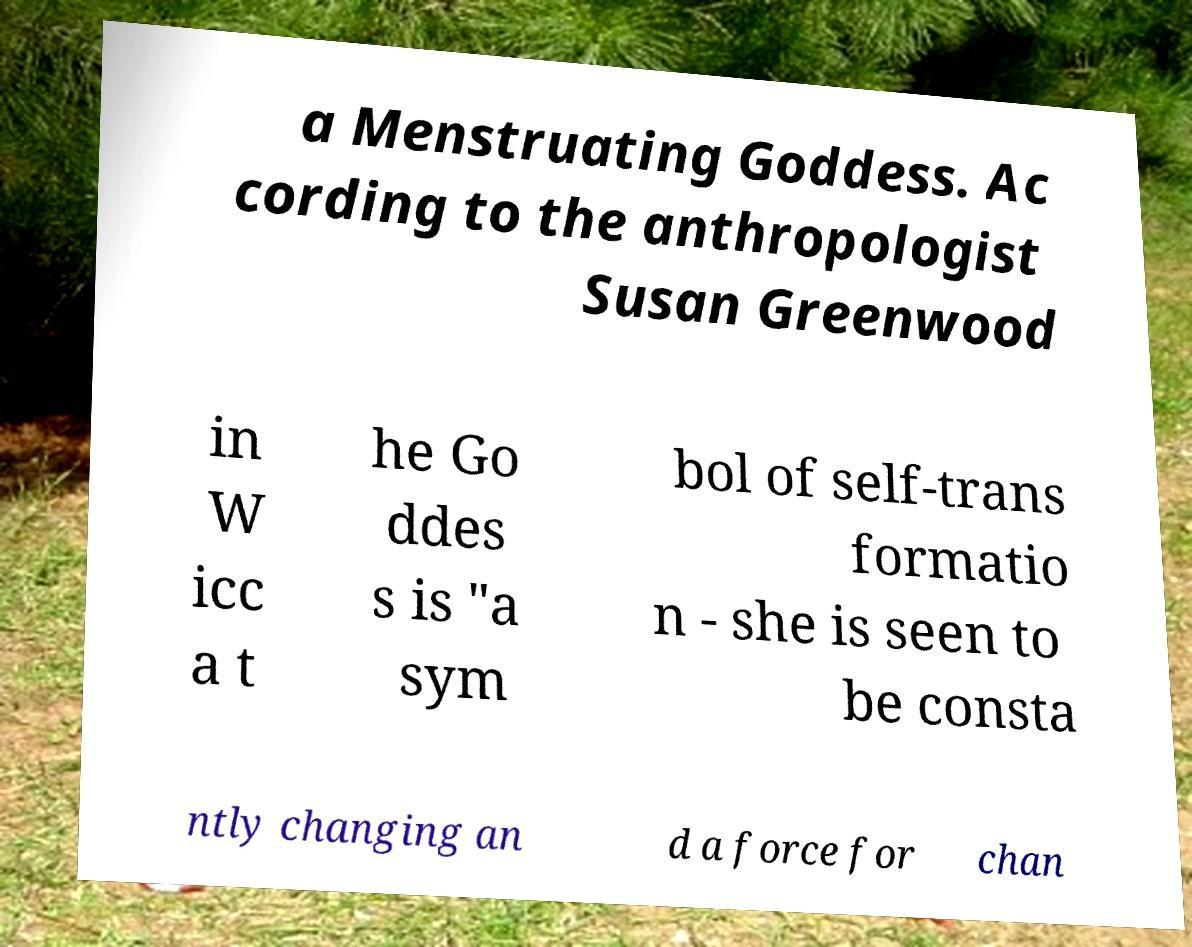Could you assist in decoding the text presented in this image and type it out clearly? a Menstruating Goddess. Ac cording to the anthropologist Susan Greenwood in W icc a t he Go ddes s is "a sym bol of self-trans formatio n - she is seen to be consta ntly changing an d a force for chan 